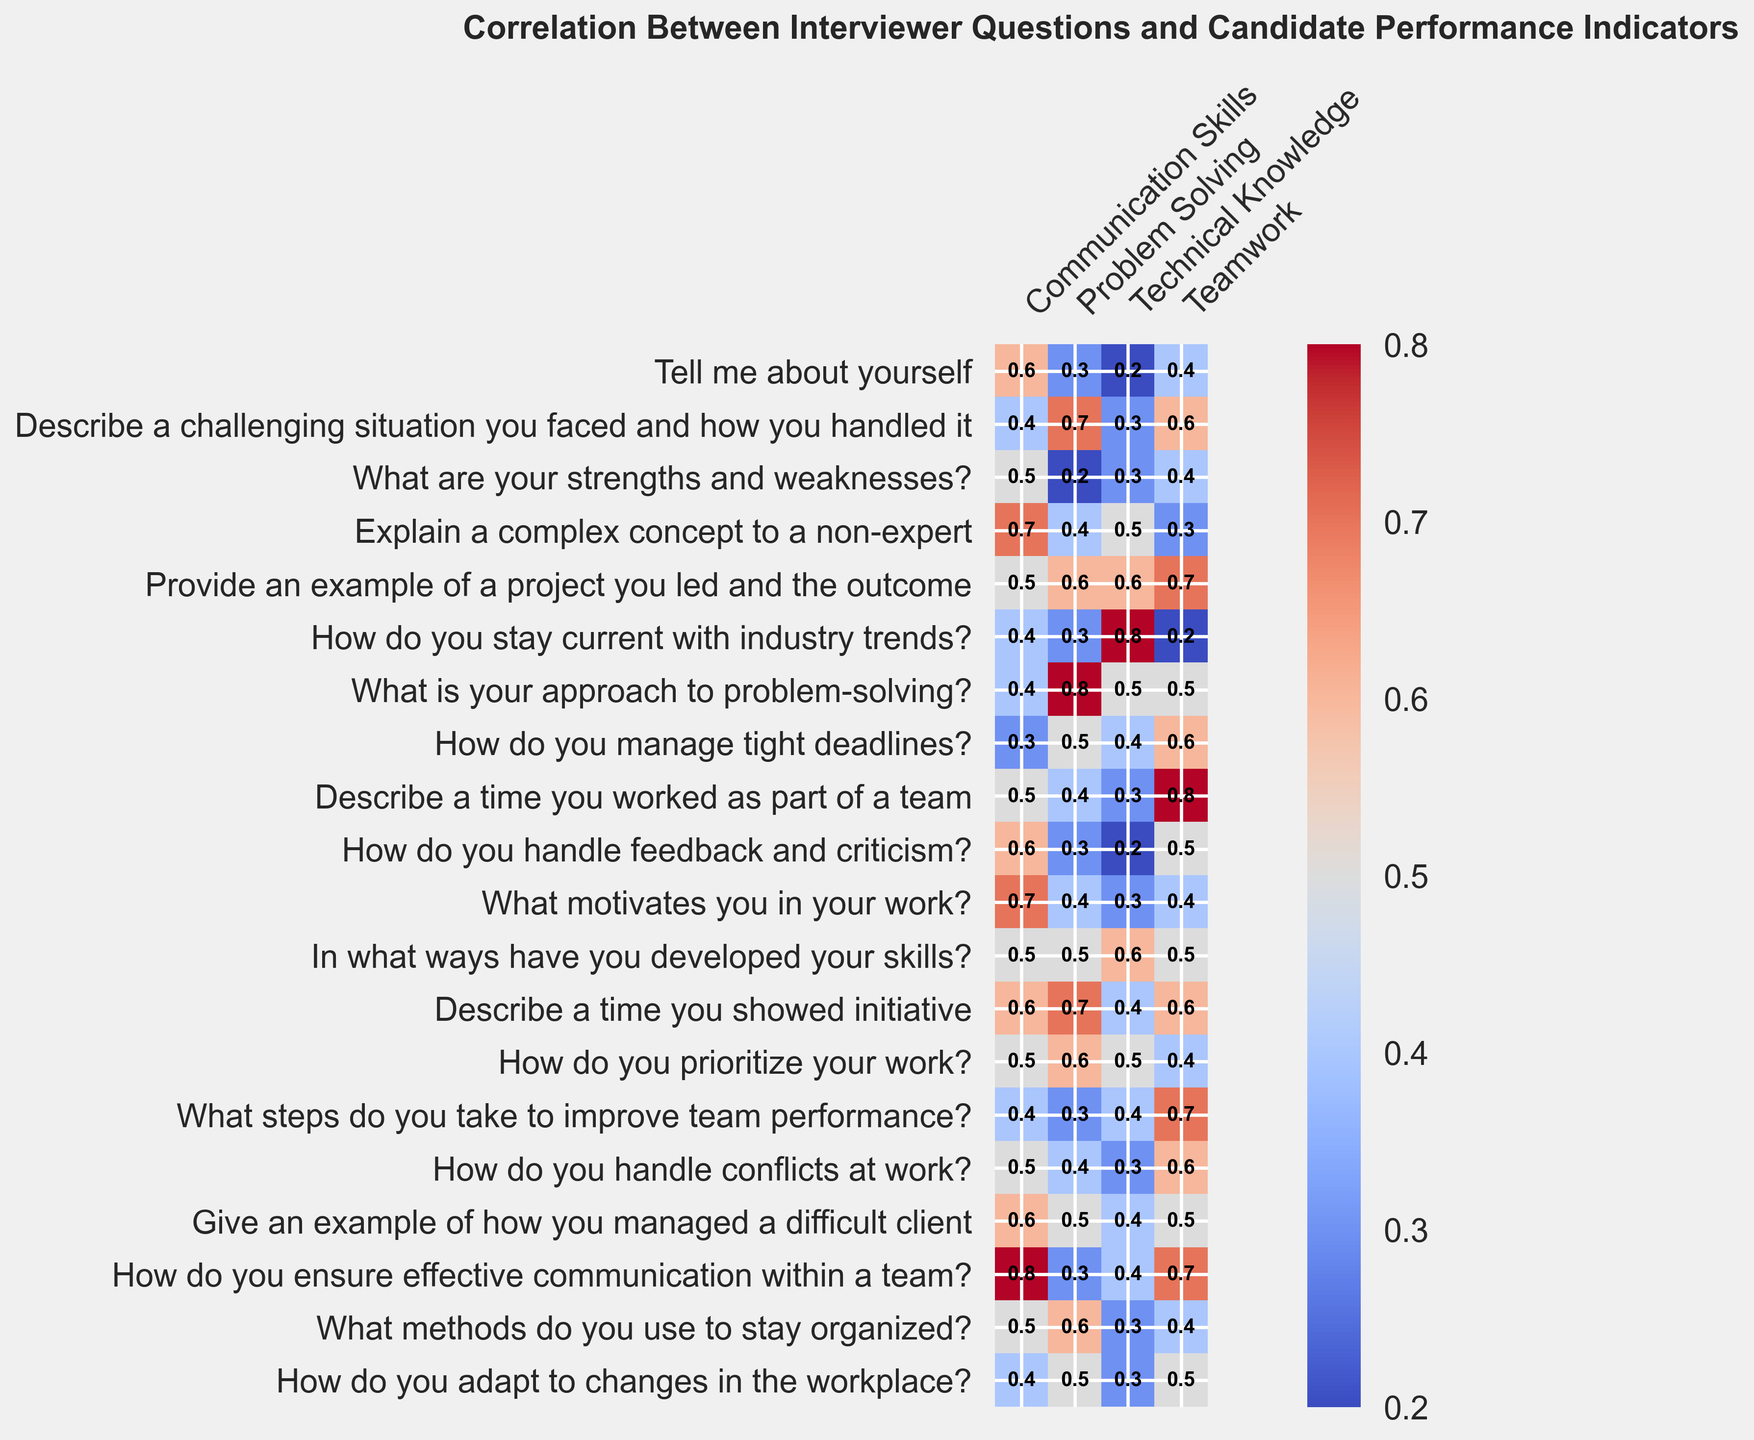What question about "Explain a complex concept to a non-expert" is related to "Problem Solving" the most? By looking at the heatmap intersection of "Explain a complex concept to a non-expert" and "Problem Solving", you'll see that the value is 0.4, indicating a moderate correlation. The highest correlation for "Problem Solving" actually comes from "What is your approach to problem-solving?" with a value of 0.8, but it's not related to "Explain a complex concept to a non-expert."
Answer: What is your approach to problem-solving? Which question shows the highest correlation with "Teamwork"? The highest value in the "Teamwork" column needs to be identified. Here, "Describe a time you worked as part of a team" correlates the most with a value of 0.8.
Answer: Describe a time you worked as part of a team What is the average correlation of "Describe a challenging situation you faced and how you handled it" with all the performance indicators? To find the average, sum the correlation values (0.4 + 0.7 + 0.3 + 0.6) and then divide by the number of indicators, which is 4. Calculation: (0.4 + 0.7 + 0.3 + 0.6) / 4 = 2.0 / 4 = 0.5.
Answer: 0.5 Is "How do you ensure effective communication within a team?" more correlated with "Communication Skills" or "Teamwork"? Look at the values for "How do you ensure effective communication within a team?" under both "Communication Skills" and "Teamwork". The correlation with "Communication Skills" is 0.8, and with "Teamwork" is 0.7. Thus, it is more correlated with "Communication Skills".
Answer: Communication Skills Compare the correlation of "Tell me about yourself" and "Explain a complex concept to a non-expert" for "Communication Skills". Which is higher? Check the values for both questions under the "Communication Skills" column. "Tell me about yourself" has a correlation of 0.6, and "Explain a complex concept to a non-expert" has a correlation of 0.7. Hence, "Explain a complex concept to a non-expert" has a higher correlation.
Answer: Explain a complex concept to a non-expert What is the difference in correlation values between "Describe a time you showed initiative" and "How do you adapt to changes in the workplace?" for "Technical Knowledge"? Look at the "Technical Knowledge" column values for both questions. "Describe a time you showed initiative" has a correlation of 0.4, and "How do you adapt to changes in the workplace?" has a correlation of 0.3. The difference is 0.4 - 0.3 = 0.1.
Answer: 0.1 Which question related to "Problem Solving" has the lowest correlation with "Technical Knowledge"? Identify the correlations under the "Problem Solving" column and find the lowest value. For "Technical Knowledge," the lowest correlation is with "What are your strengths and weaknesses?" at 0.2.
Answer: What are your strengths and weaknesses? How does the correlation of "How do you manage tight deadlines?" with "Teamwork" compare to "Problem Solving"? Check the values for "How do you manage tight deadlines?" under both the "Teamwork" and "Problem Solving" columns. The correlation with "Teamwork" is 0.6, and with "Problem Solving" is 0.5. Thus, it shows a higher correlation with "Teamwork".
Answer: Teamwork 